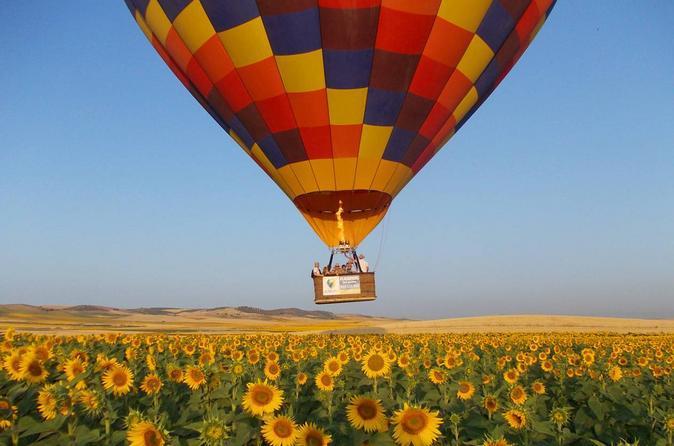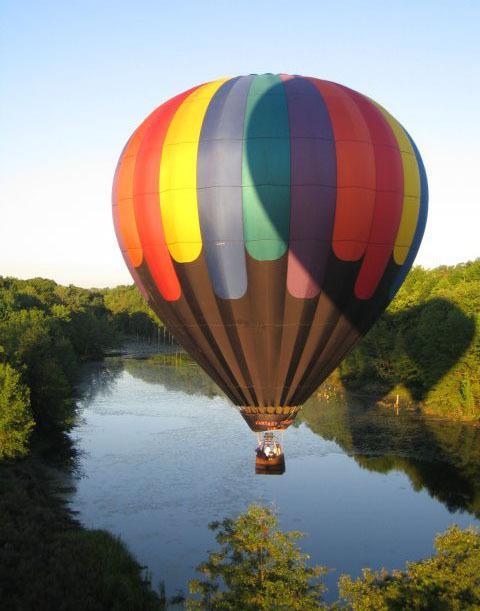The first image is the image on the left, the second image is the image on the right. Given the left and right images, does the statement "There are no more than two hot air balloons." hold true? Answer yes or no. Yes. The first image is the image on the left, the second image is the image on the right. Evaluate the accuracy of this statement regarding the images: "One of the images has at least one hot air balloon with characters or pictures on it.". Is it true? Answer yes or no. No. 